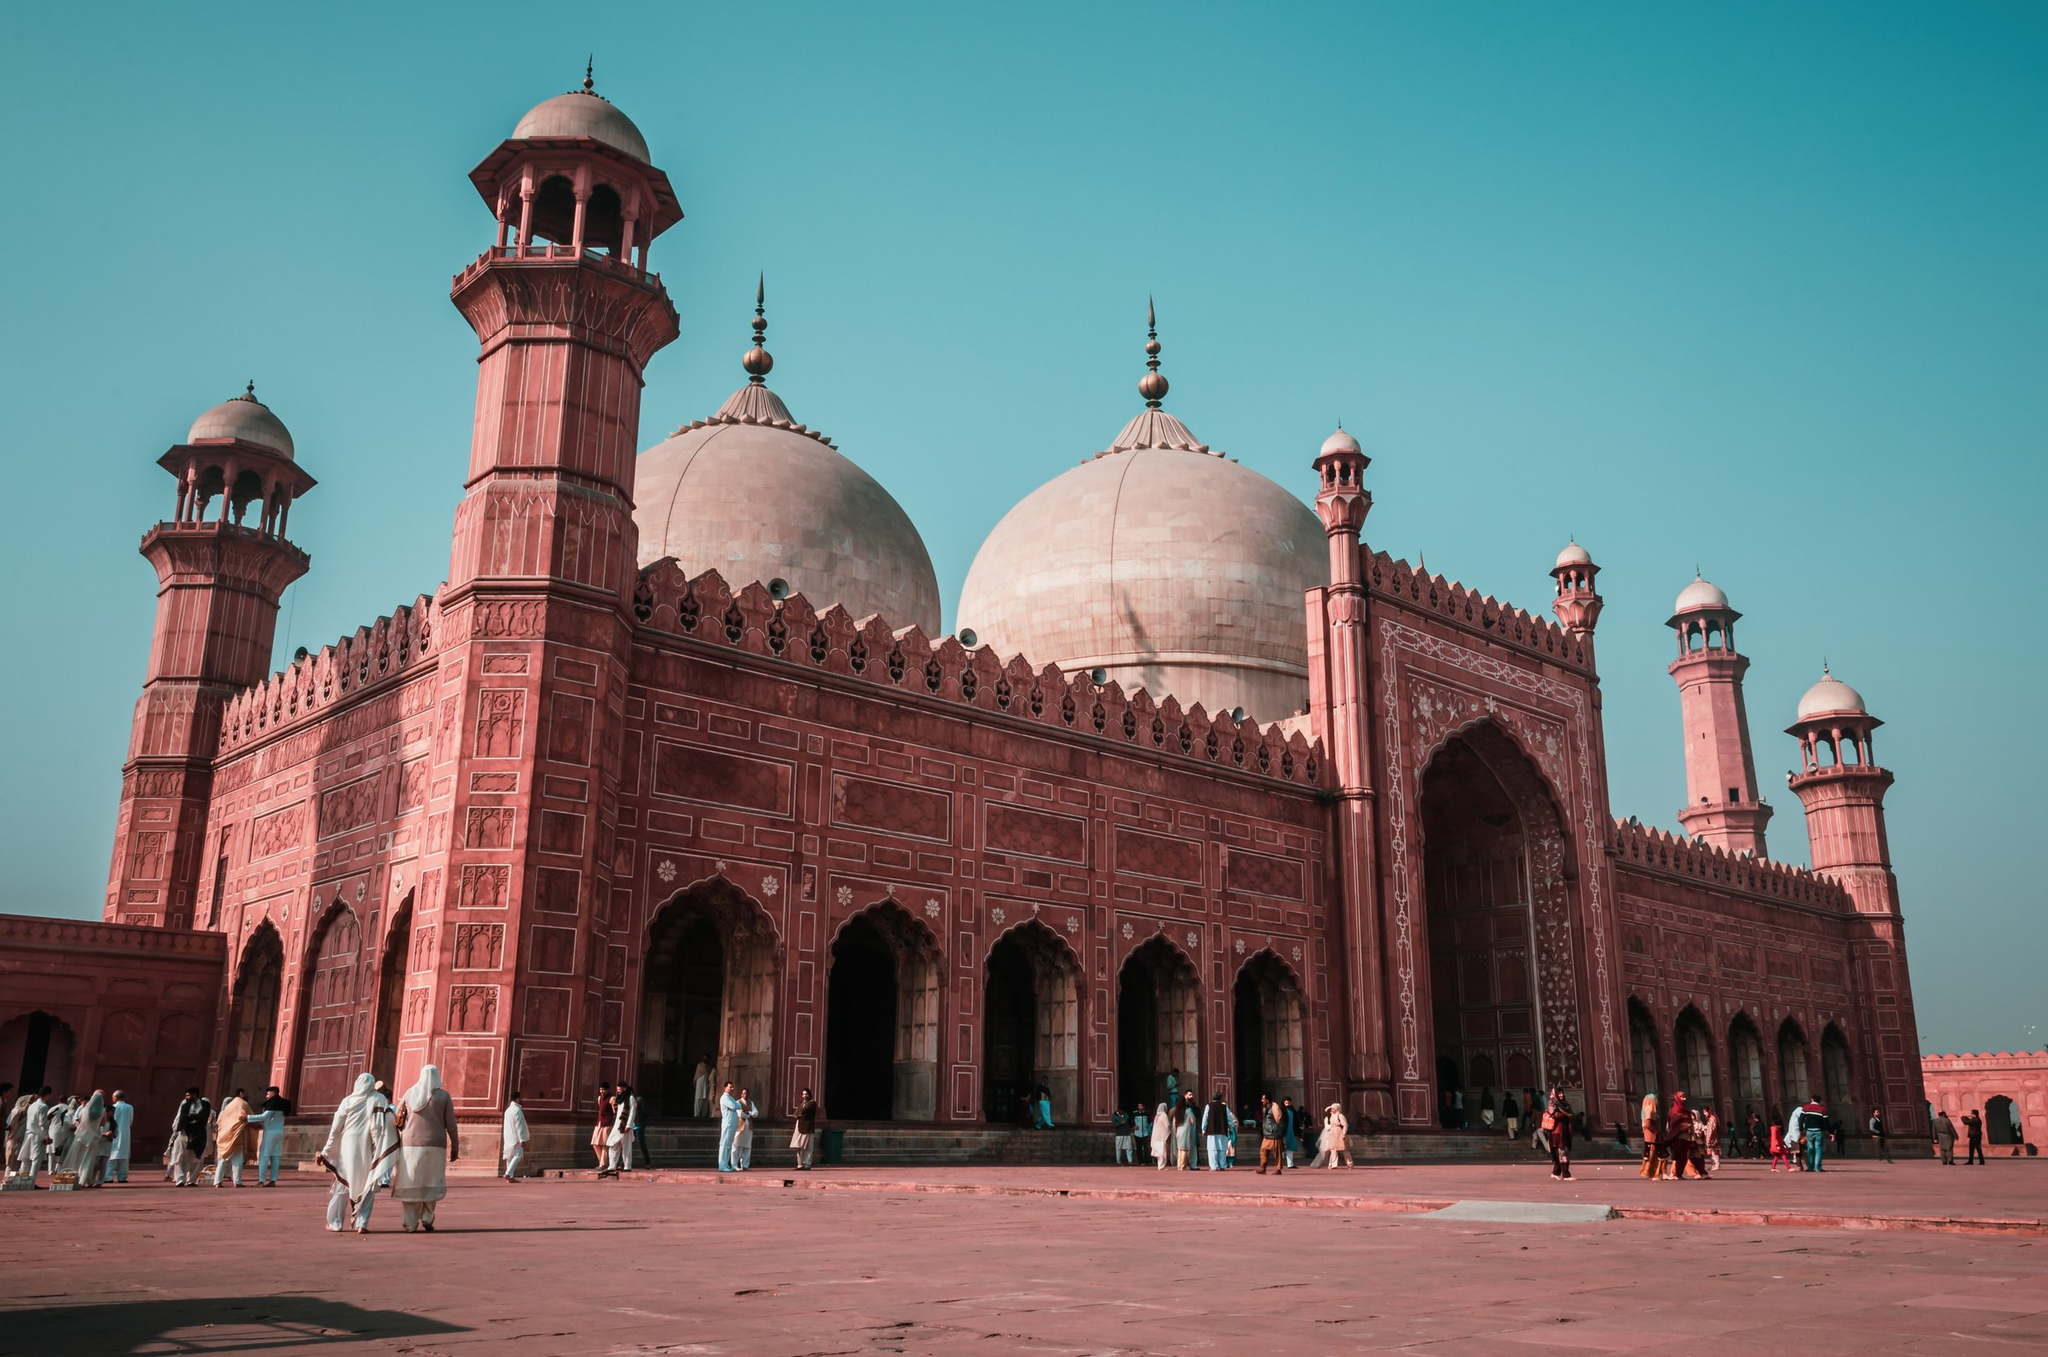If the mosque was transformed into an intergalactic beacon, what might it signal to the universe? In the realm of imagination, transformed into a shimmering intergalactic beacon, the mosque would send waves of tranquility and wisdom across the cosmos. Its signal, an ethereal blend of ancient chants and cosmic frequencies, would resonate with distant civilizations, inviting them to connect and share knowledge. The grandeur of its structure would serve as a symbol of universal unity, representing Earth's historical richness and spiritual diversity. The intricate designs and towering minarets would emit beams of light, creating an interstellar map guiding curious beings to a sanctuary of peace and enlightenment. This cosmic beacon would become a bridge, fostering intergalactic harmony and a profound understanding of the shared pursuit of knowledge and spiritual growth. 